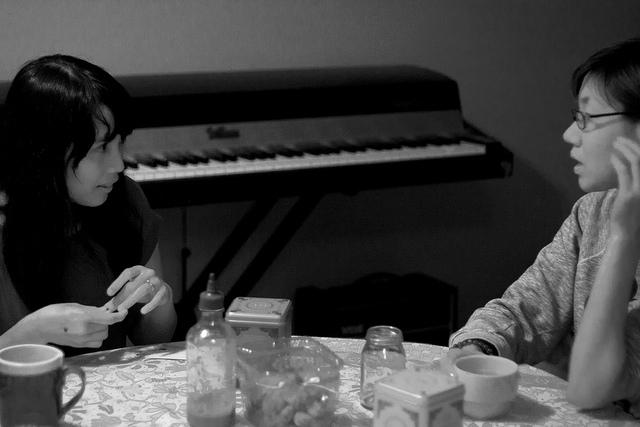Is anyone playing the organ?
Short answer required. No. Is this a restaurant?
Concise answer only. No. Is the pic in color?
Answer briefly. No. 